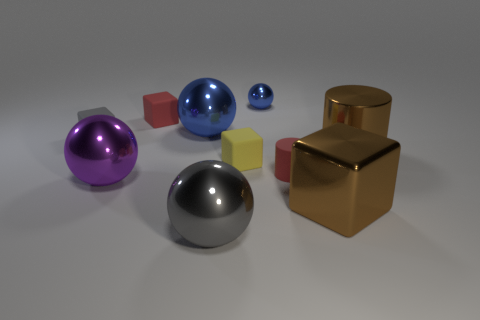Subtract all cylinders. How many objects are left? 8 Subtract all green cylinders. Subtract all gray matte blocks. How many objects are left? 9 Add 1 small gray matte cubes. How many small gray matte cubes are left? 2 Add 5 big brown cylinders. How many big brown cylinders exist? 6 Subtract 0 cyan cubes. How many objects are left? 10 